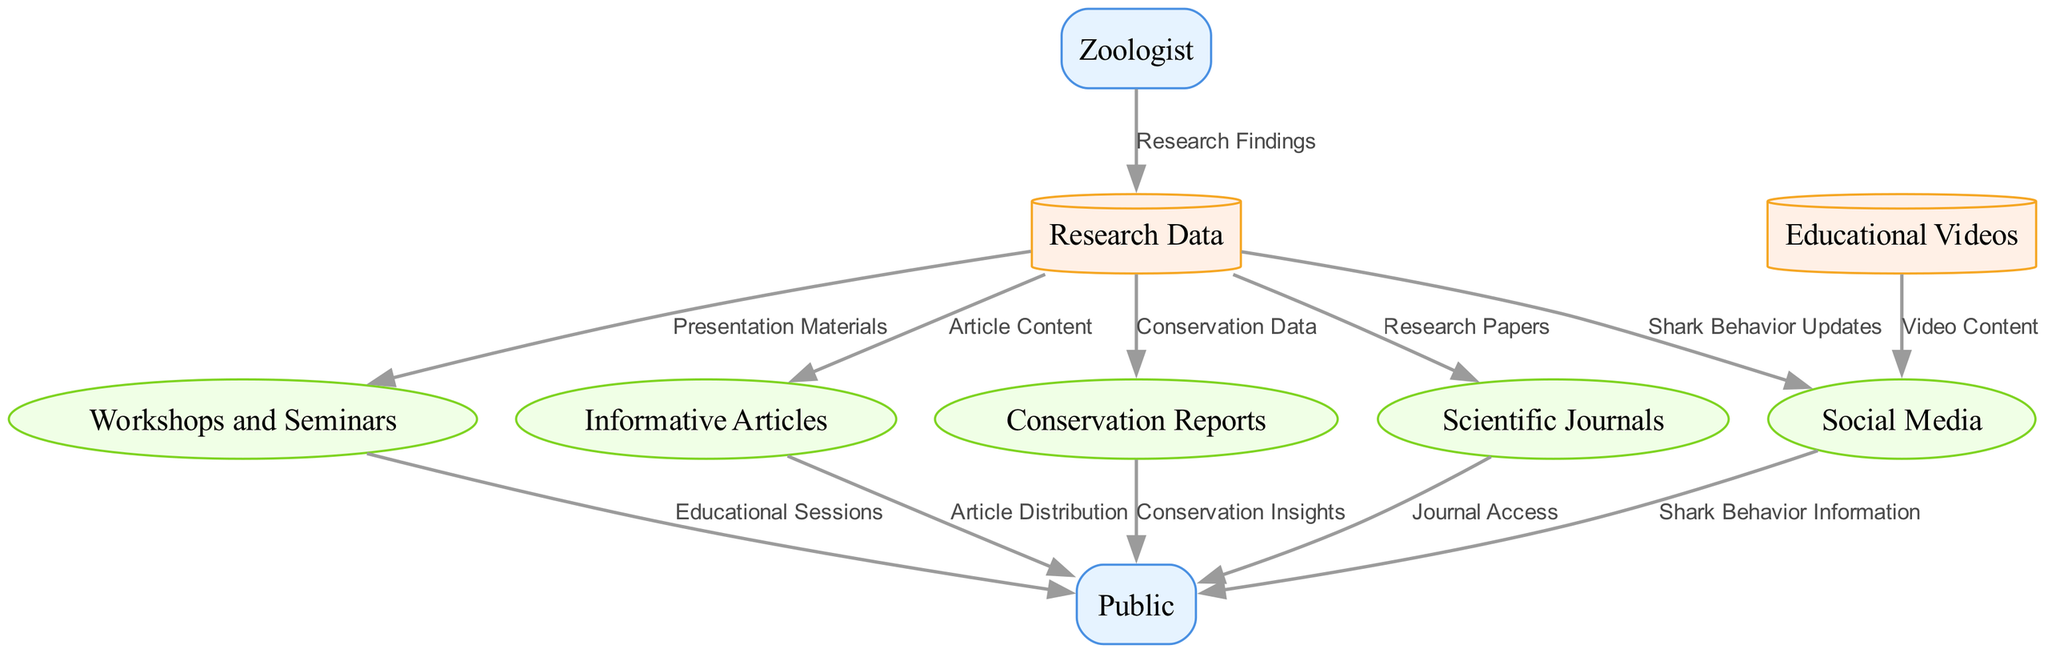What are the two external entities in the diagram? The diagram has two external entities listed: the Zoologist and the Public. These are represented as rectangles, denoting their roles outside the main processes and data stores.
Answer: Zoologist, Public How many data stores are there in the diagram? There are five data stores in the diagram: Research Data, Educational Videos, and four others specifically named. Counting these, we arrive at a total of five.
Answer: 5 Which process receives Presentation Materials? The Workshops and Seminars process receives Presentation Materials from the Research Data data store. This is indicated by the flow lines connecting these two nodes.
Answer: Workshops and Seminars What type of information is distributed to the Public from Social Media? The information about Shark Behavior is distributed from Social Media to the Public. This is explicitly shown as a data flow labeled "Shark Behavior Information."
Answer: Shark Behavior Information How many processes are there in total? The diagram features five processes: Social Media, Workshops and Seminars, Informative Articles, Conservation Reports, and Scientific Journals. These are each represented as ellipses within the diagram.
Answer: 5 What is the relationship between Research Data and Social Media? The relationship is that Research Data provides Shark Behavior Updates to Social Media. This flow indicates that the social media process relies on information gathered from the research data store.
Answer: Shark Behavior Updates Which data store provides Video Content to Social Media? The Educational Videos data store provides Video Content to Social Media, establishing a direct flow of information in the diagram.
Answer: Educational Videos Which external entity is the recipient of Educational Sessions? The Public is the recipient of Educational Sessions, which are a product of the Workshops and Seminars process, as indicated by the connecting edge in the diagram.
Answer: Public What type of reports does the Public receive through Conservation Reports? The Public receives Conservation Insights through the Conservation Reports process, which conveys important data regarding conservation efforts.
Answer: Conservation Insights 